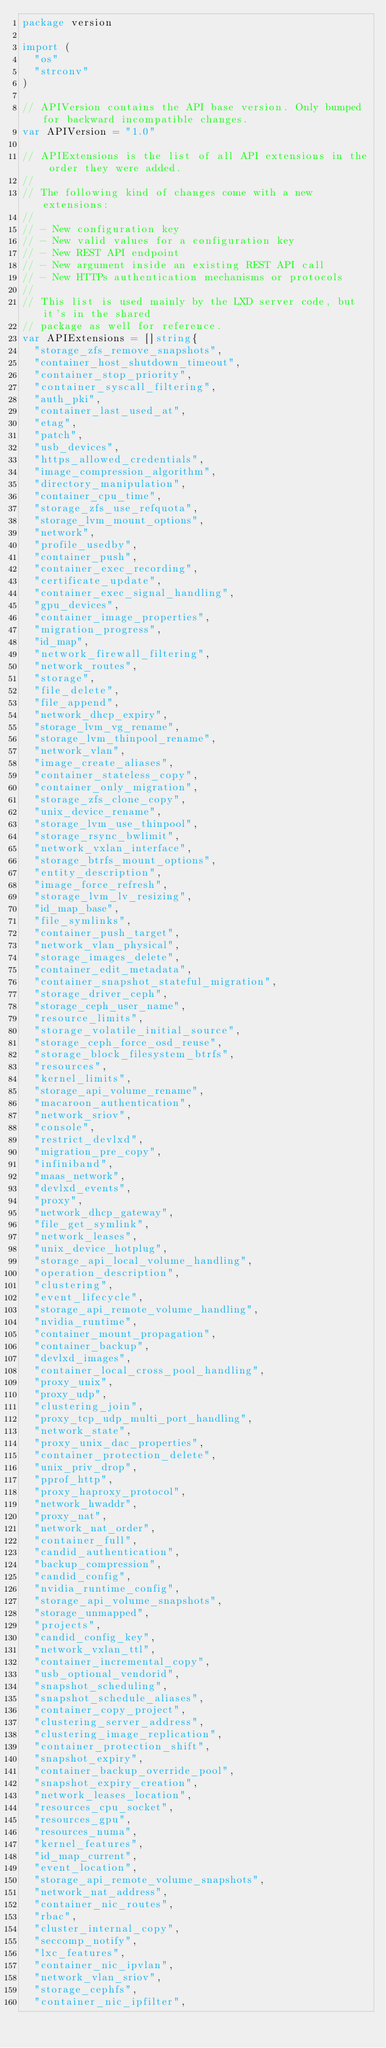<code> <loc_0><loc_0><loc_500><loc_500><_Go_>package version

import (
	"os"
	"strconv"
)

// APIVersion contains the API base version. Only bumped for backward incompatible changes.
var APIVersion = "1.0"

// APIExtensions is the list of all API extensions in the order they were added.
//
// The following kind of changes come with a new extensions:
//
// - New configuration key
// - New valid values for a configuration key
// - New REST API endpoint
// - New argument inside an existing REST API call
// - New HTTPs authentication mechanisms or protocols
//
// This list is used mainly by the LXD server code, but it's in the shared
// package as well for reference.
var APIExtensions = []string{
	"storage_zfs_remove_snapshots",
	"container_host_shutdown_timeout",
	"container_stop_priority",
	"container_syscall_filtering",
	"auth_pki",
	"container_last_used_at",
	"etag",
	"patch",
	"usb_devices",
	"https_allowed_credentials",
	"image_compression_algorithm",
	"directory_manipulation",
	"container_cpu_time",
	"storage_zfs_use_refquota",
	"storage_lvm_mount_options",
	"network",
	"profile_usedby",
	"container_push",
	"container_exec_recording",
	"certificate_update",
	"container_exec_signal_handling",
	"gpu_devices",
	"container_image_properties",
	"migration_progress",
	"id_map",
	"network_firewall_filtering",
	"network_routes",
	"storage",
	"file_delete",
	"file_append",
	"network_dhcp_expiry",
	"storage_lvm_vg_rename",
	"storage_lvm_thinpool_rename",
	"network_vlan",
	"image_create_aliases",
	"container_stateless_copy",
	"container_only_migration",
	"storage_zfs_clone_copy",
	"unix_device_rename",
	"storage_lvm_use_thinpool",
	"storage_rsync_bwlimit",
	"network_vxlan_interface",
	"storage_btrfs_mount_options",
	"entity_description",
	"image_force_refresh",
	"storage_lvm_lv_resizing",
	"id_map_base",
	"file_symlinks",
	"container_push_target",
	"network_vlan_physical",
	"storage_images_delete",
	"container_edit_metadata",
	"container_snapshot_stateful_migration",
	"storage_driver_ceph",
	"storage_ceph_user_name",
	"resource_limits",
	"storage_volatile_initial_source",
	"storage_ceph_force_osd_reuse",
	"storage_block_filesystem_btrfs",
	"resources",
	"kernel_limits",
	"storage_api_volume_rename",
	"macaroon_authentication",
	"network_sriov",
	"console",
	"restrict_devlxd",
	"migration_pre_copy",
	"infiniband",
	"maas_network",
	"devlxd_events",
	"proxy",
	"network_dhcp_gateway",
	"file_get_symlink",
	"network_leases",
	"unix_device_hotplug",
	"storage_api_local_volume_handling",
	"operation_description",
	"clustering",
	"event_lifecycle",
	"storage_api_remote_volume_handling",
	"nvidia_runtime",
	"container_mount_propagation",
	"container_backup",
	"devlxd_images",
	"container_local_cross_pool_handling",
	"proxy_unix",
	"proxy_udp",
	"clustering_join",
	"proxy_tcp_udp_multi_port_handling",
	"network_state",
	"proxy_unix_dac_properties",
	"container_protection_delete",
	"unix_priv_drop",
	"pprof_http",
	"proxy_haproxy_protocol",
	"network_hwaddr",
	"proxy_nat",
	"network_nat_order",
	"container_full",
	"candid_authentication",
	"backup_compression",
	"candid_config",
	"nvidia_runtime_config",
	"storage_api_volume_snapshots",
	"storage_unmapped",
	"projects",
	"candid_config_key",
	"network_vxlan_ttl",
	"container_incremental_copy",
	"usb_optional_vendorid",
	"snapshot_scheduling",
	"snapshot_schedule_aliases",
	"container_copy_project",
	"clustering_server_address",
	"clustering_image_replication",
	"container_protection_shift",
	"snapshot_expiry",
	"container_backup_override_pool",
	"snapshot_expiry_creation",
	"network_leases_location",
	"resources_cpu_socket",
	"resources_gpu",
	"resources_numa",
	"kernel_features",
	"id_map_current",
	"event_location",
	"storage_api_remote_volume_snapshots",
	"network_nat_address",
	"container_nic_routes",
	"rbac",
	"cluster_internal_copy",
	"seccomp_notify",
	"lxc_features",
	"container_nic_ipvlan",
	"network_vlan_sriov",
	"storage_cephfs",
	"container_nic_ipfilter",</code> 